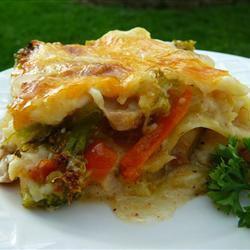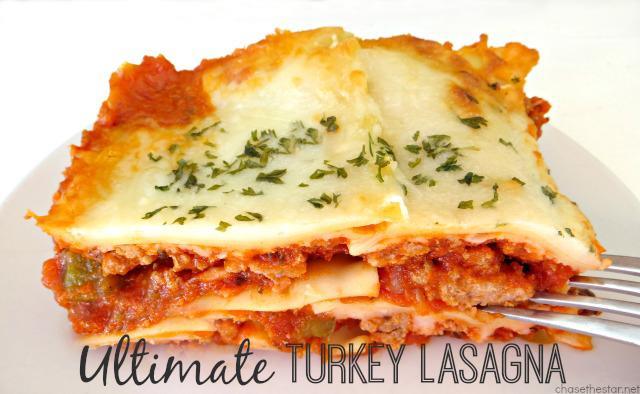The first image is the image on the left, the second image is the image on the right. Considering the images on both sides, is "There is a green leafy garnish on one of the plates of food." valid? Answer yes or no. Yes. 